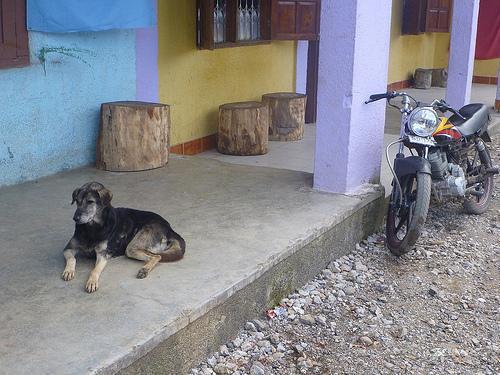How many of the dog's paws can be seen?
Give a very brief answer. 3. 